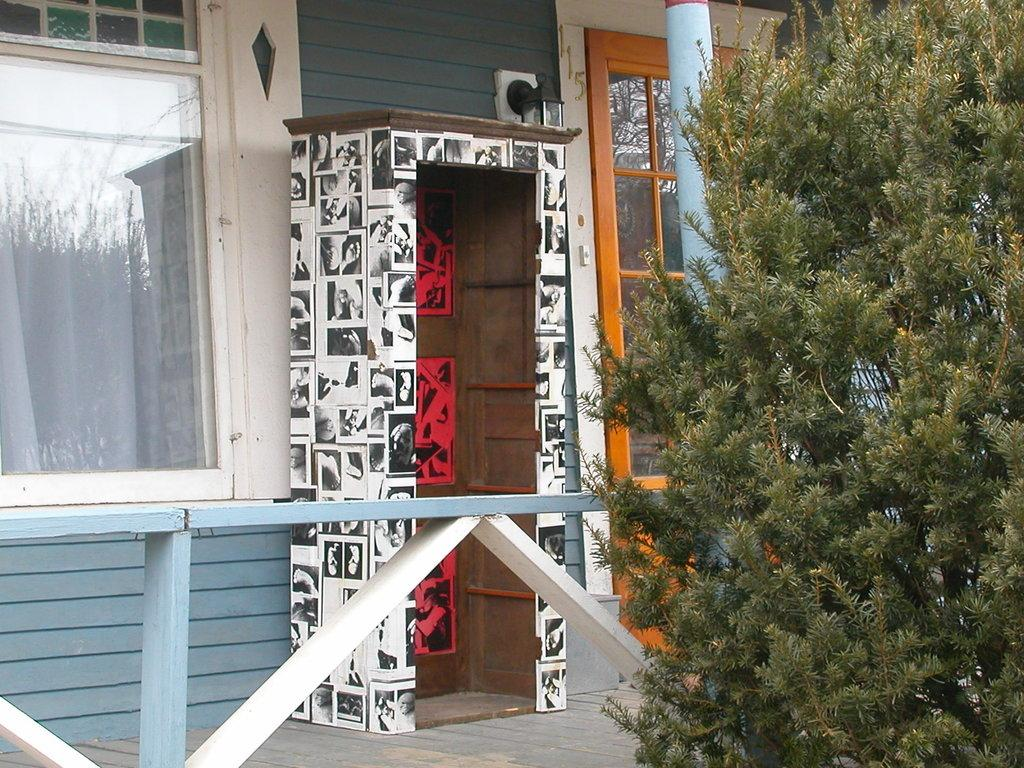What type of vegetation is on the right side of the image? There is a tree on the right side of the image. What architectural features can be seen in the image? There is a wall, a pillar, and glass windows in the image. What is visible through the windows in the image? A white curtain is visible through the window. What type of rhythm can be heard coming from the chickens in the image? There are no chickens present in the image, so there is no rhythm to be heard. 